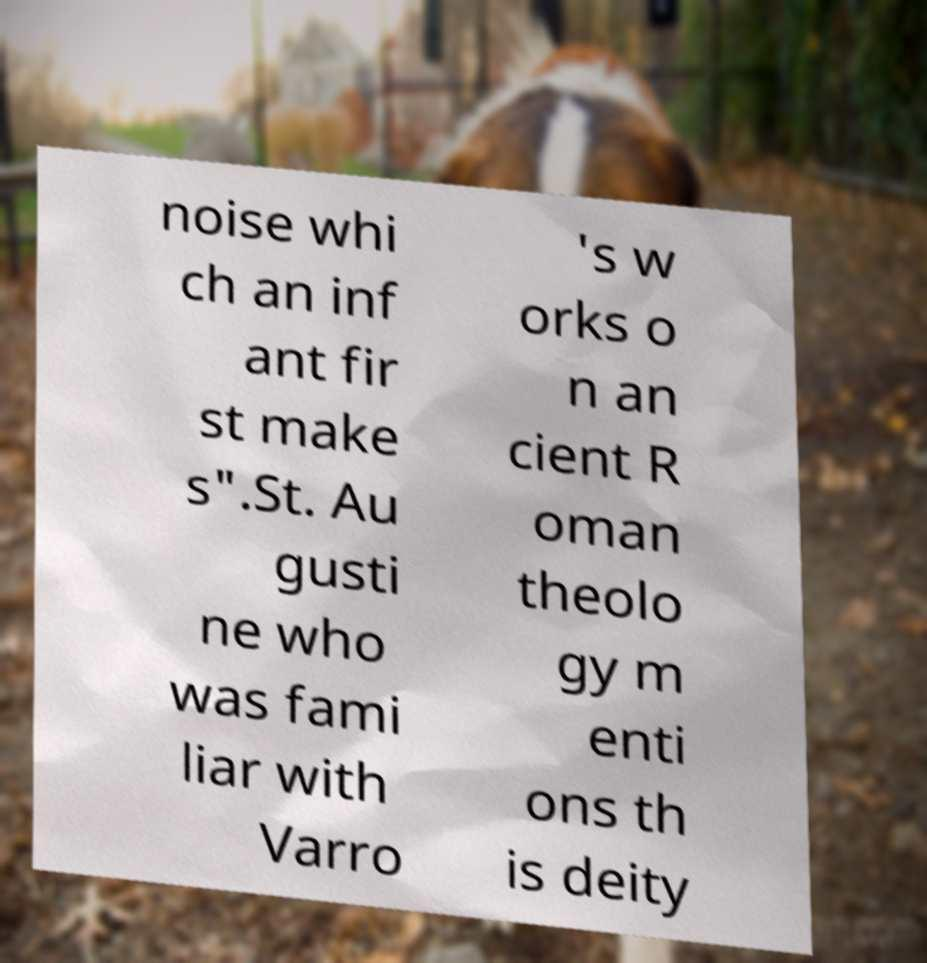What messages or text are displayed in this image? I need them in a readable, typed format. noise whi ch an inf ant fir st make s".St. Au gusti ne who was fami liar with Varro 's w orks o n an cient R oman theolo gy m enti ons th is deity 